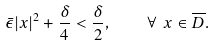Convert formula to latex. <formula><loc_0><loc_0><loc_500><loc_500>\bar { \epsilon } | x | ^ { 2 } + \frac { \delta } { 4 } < \frac { \delta } { 2 } , \quad \forall \ x \in \overline { D } .</formula> 